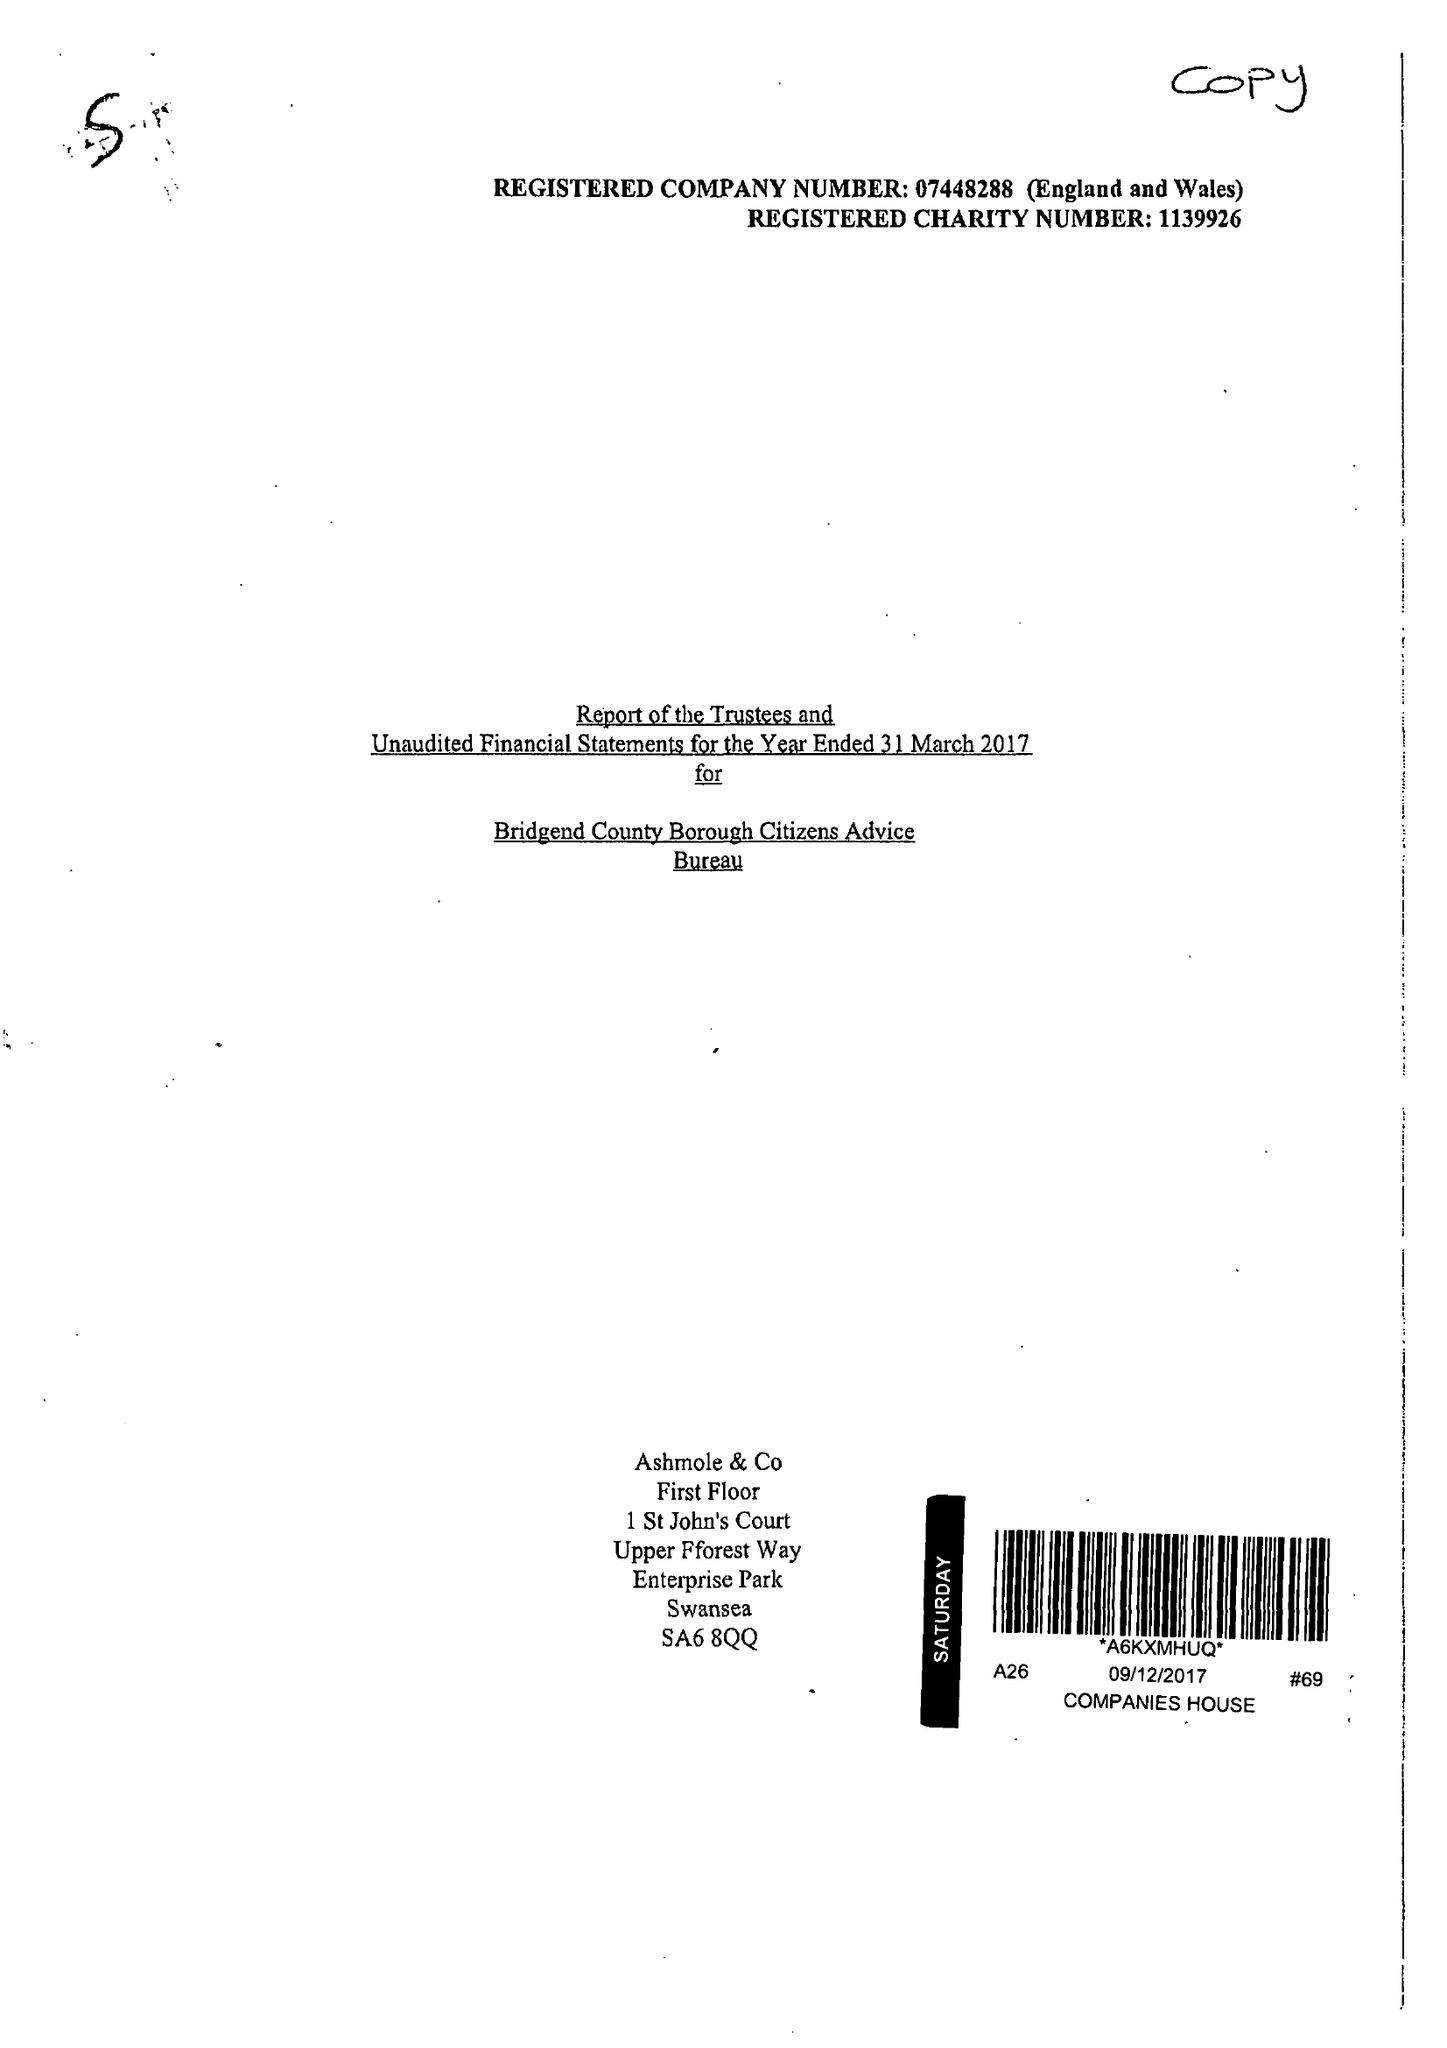What is the value for the address__postcode?
Answer the question using a single word or phrase. CF31 1JD 